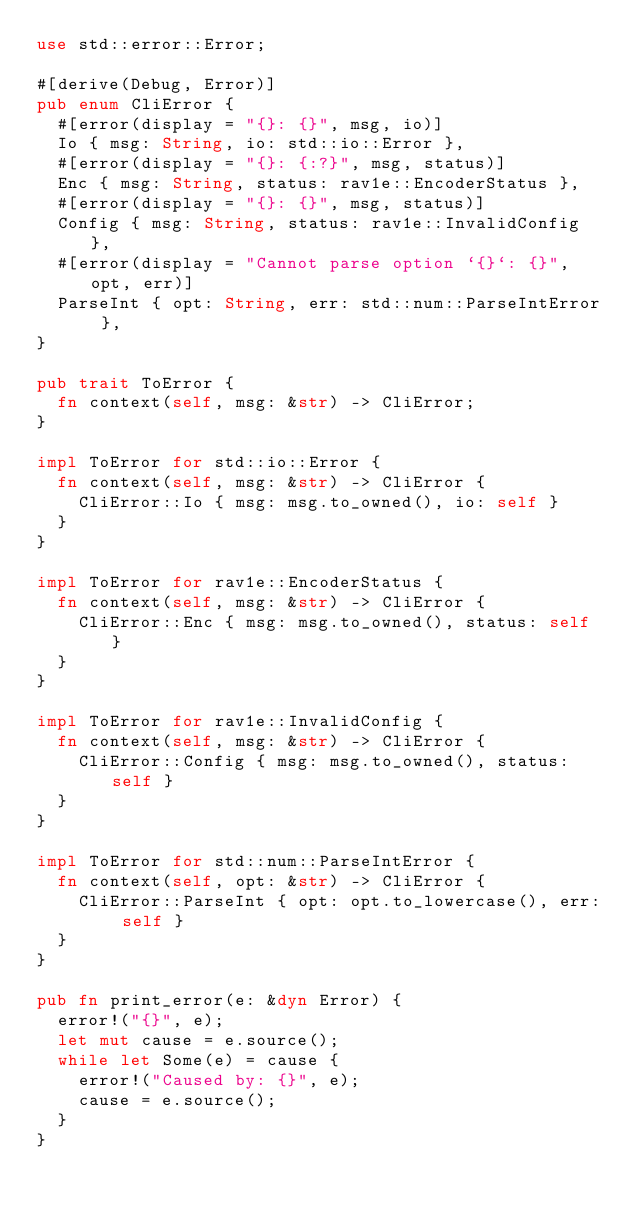Convert code to text. <code><loc_0><loc_0><loc_500><loc_500><_Rust_>use std::error::Error;

#[derive(Debug, Error)]
pub enum CliError {
  #[error(display = "{}: {}", msg, io)]
  Io { msg: String, io: std::io::Error },
  #[error(display = "{}: {:?}", msg, status)]
  Enc { msg: String, status: rav1e::EncoderStatus },
  #[error(display = "{}: {}", msg, status)]
  Config { msg: String, status: rav1e::InvalidConfig },
  #[error(display = "Cannot parse option `{}`: {}", opt, err)]
  ParseInt { opt: String, err: std::num::ParseIntError },
}

pub trait ToError {
  fn context(self, msg: &str) -> CliError;
}

impl ToError for std::io::Error {
  fn context(self, msg: &str) -> CliError {
    CliError::Io { msg: msg.to_owned(), io: self }
  }
}

impl ToError for rav1e::EncoderStatus {
  fn context(self, msg: &str) -> CliError {
    CliError::Enc { msg: msg.to_owned(), status: self }
  }
}

impl ToError for rav1e::InvalidConfig {
  fn context(self, msg: &str) -> CliError {
    CliError::Config { msg: msg.to_owned(), status: self }
  }
}

impl ToError for std::num::ParseIntError {
  fn context(self, opt: &str) -> CliError {
    CliError::ParseInt { opt: opt.to_lowercase(), err: self }
  }
}

pub fn print_error(e: &dyn Error) {
  error!("{}", e);
  let mut cause = e.source();
  while let Some(e) = cause {
    error!("Caused by: {}", e);
    cause = e.source();
  }
}
</code> 